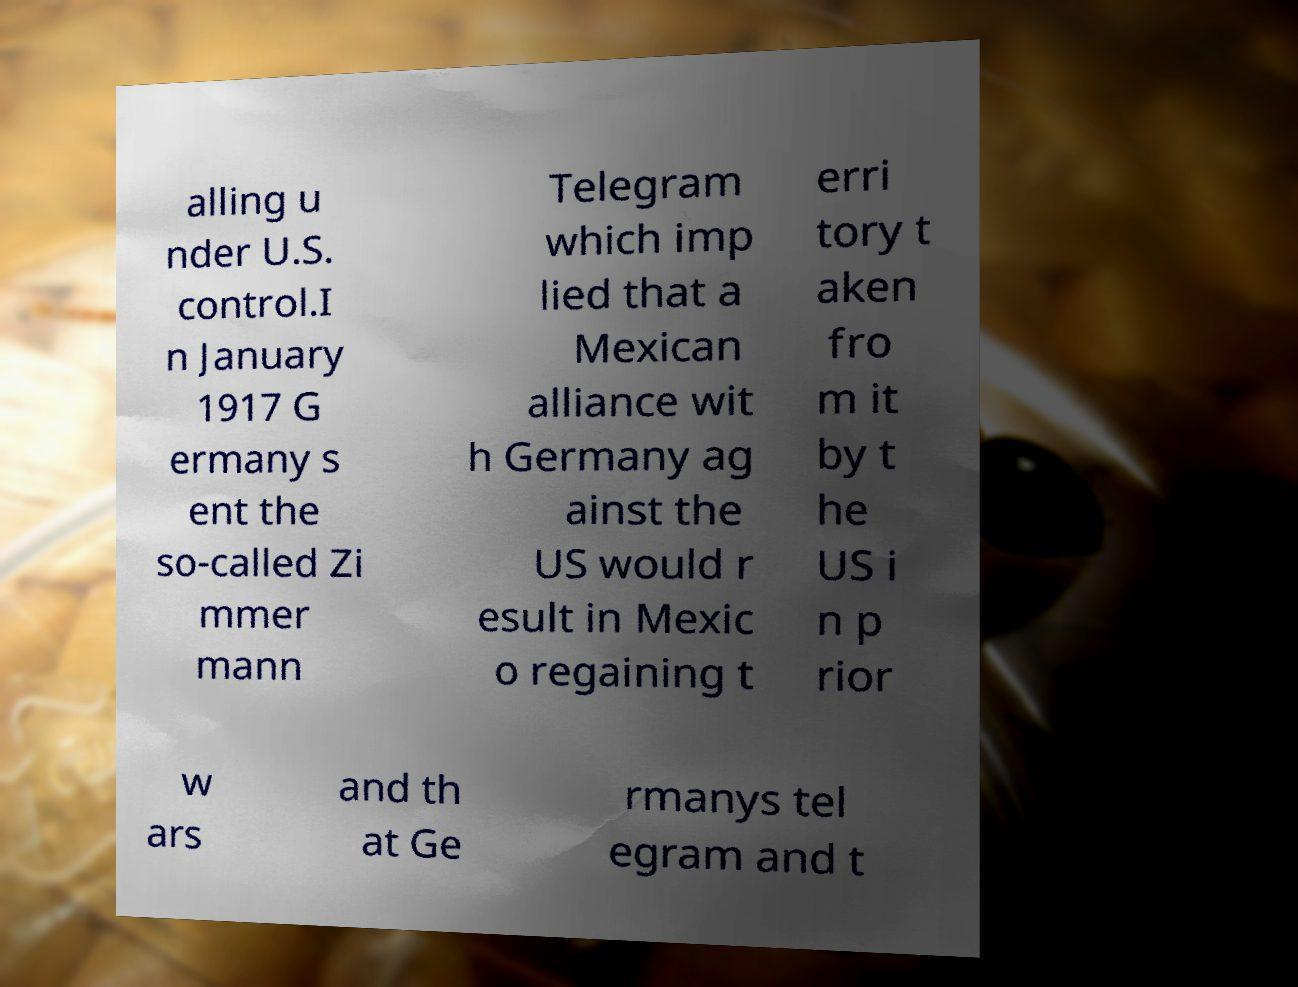Can you accurately transcribe the text from the provided image for me? alling u nder U.S. control.I n January 1917 G ermany s ent the so-called Zi mmer mann Telegram which imp lied that a Mexican alliance wit h Germany ag ainst the US would r esult in Mexic o regaining t erri tory t aken fro m it by t he US i n p rior w ars and th at Ge rmanys tel egram and t 